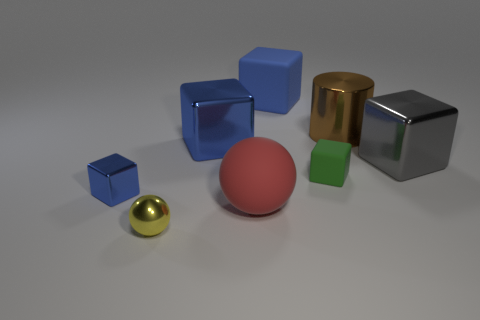Subtract all cyan spheres. How many blue cubes are left? 3 Subtract all brown blocks. Subtract all red cylinders. How many blocks are left? 5 Add 1 big metal blocks. How many objects exist? 9 Subtract all cylinders. How many objects are left? 7 Add 8 large matte blocks. How many large matte blocks are left? 9 Add 4 tiny rubber blocks. How many tiny rubber blocks exist? 5 Subtract 0 purple spheres. How many objects are left? 8 Subtract all big brown shiny things. Subtract all shiny things. How many objects are left? 2 